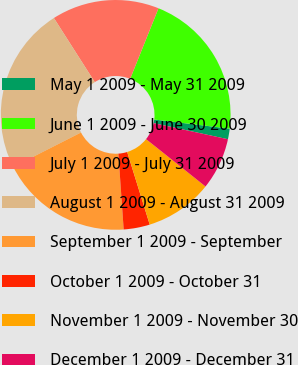Convert chart. <chart><loc_0><loc_0><loc_500><loc_500><pie_chart><fcel>May 1 2009 - May 31 2009<fcel>June 1 2009 - June 30 2009<fcel>July 1 2009 - July 31 2009<fcel>August 1 2009 - August 31 2009<fcel>September 1 2009 - September<fcel>October 1 2009 - October 31<fcel>November 1 2009 - November 30<fcel>December 1 2009 - December 31<nl><fcel>1.49%<fcel>20.83%<fcel>15.12%<fcel>23.44%<fcel>18.63%<fcel>3.68%<fcel>9.5%<fcel>7.31%<nl></chart> 